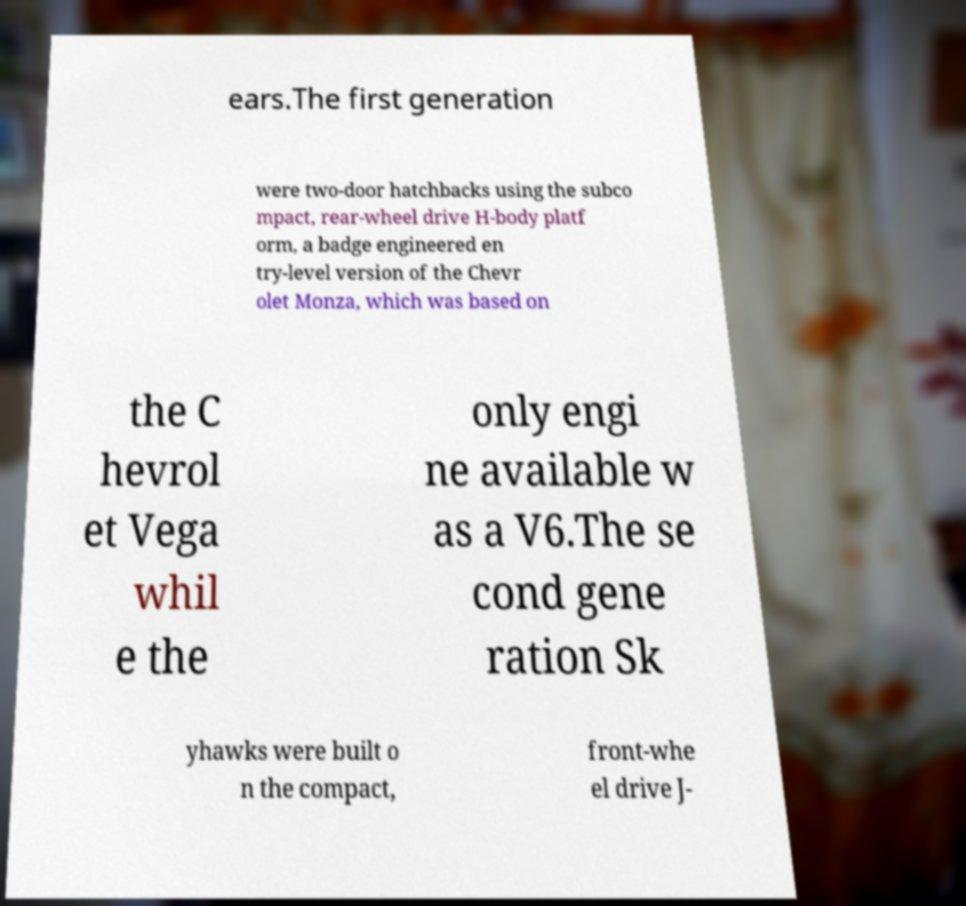There's text embedded in this image that I need extracted. Can you transcribe it verbatim? ears.The first generation were two-door hatchbacks using the subco mpact, rear-wheel drive H-body platf orm, a badge engineered en try-level version of the Chevr olet Monza, which was based on the C hevrol et Vega whil e the only engi ne available w as a V6.The se cond gene ration Sk yhawks were built o n the compact, front-whe el drive J- 